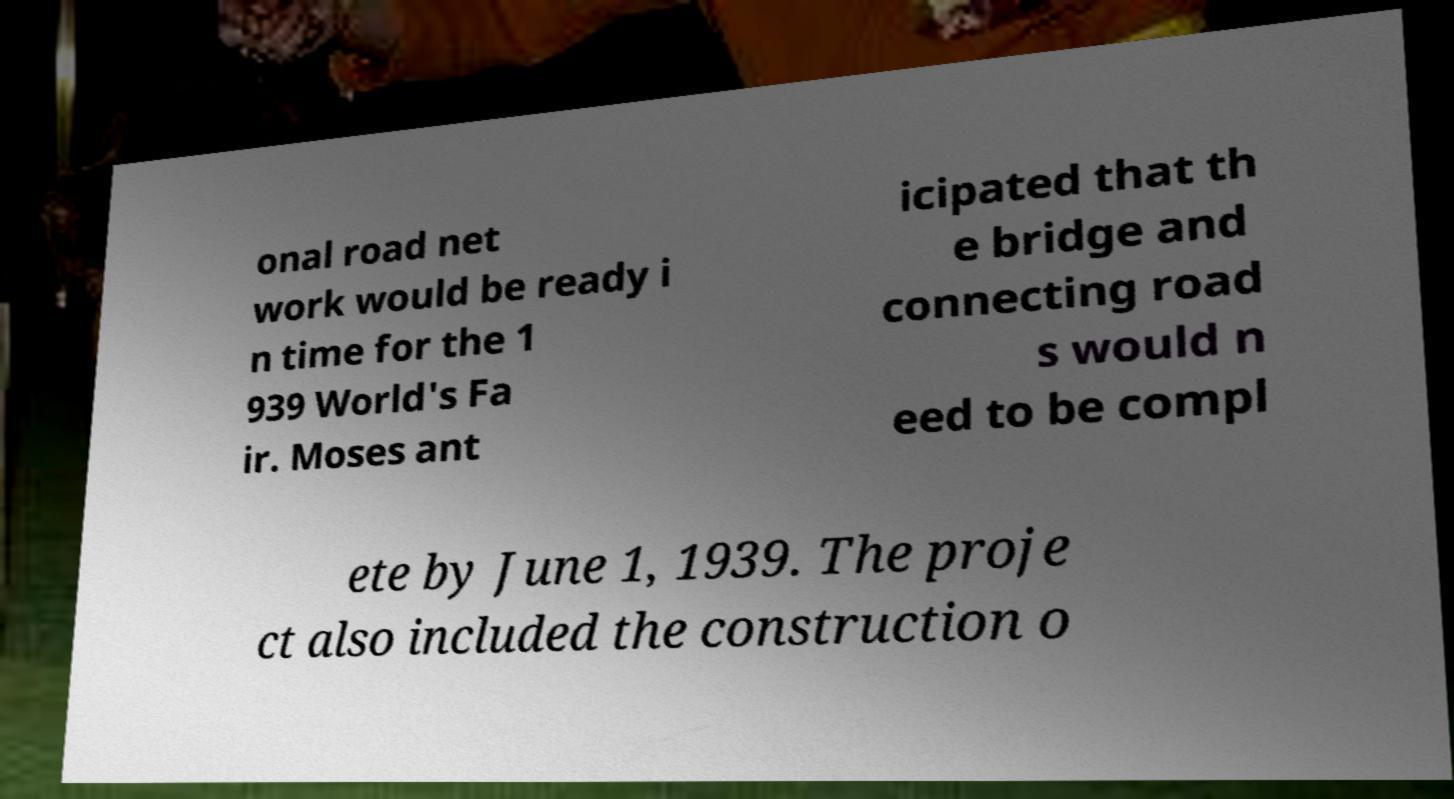What messages or text are displayed in this image? I need them in a readable, typed format. onal road net work would be ready i n time for the 1 939 World's Fa ir. Moses ant icipated that th e bridge and connecting road s would n eed to be compl ete by June 1, 1939. The proje ct also included the construction o 